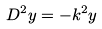<formula> <loc_0><loc_0><loc_500><loc_500>D ^ { 2 } y = - k ^ { 2 } y</formula> 